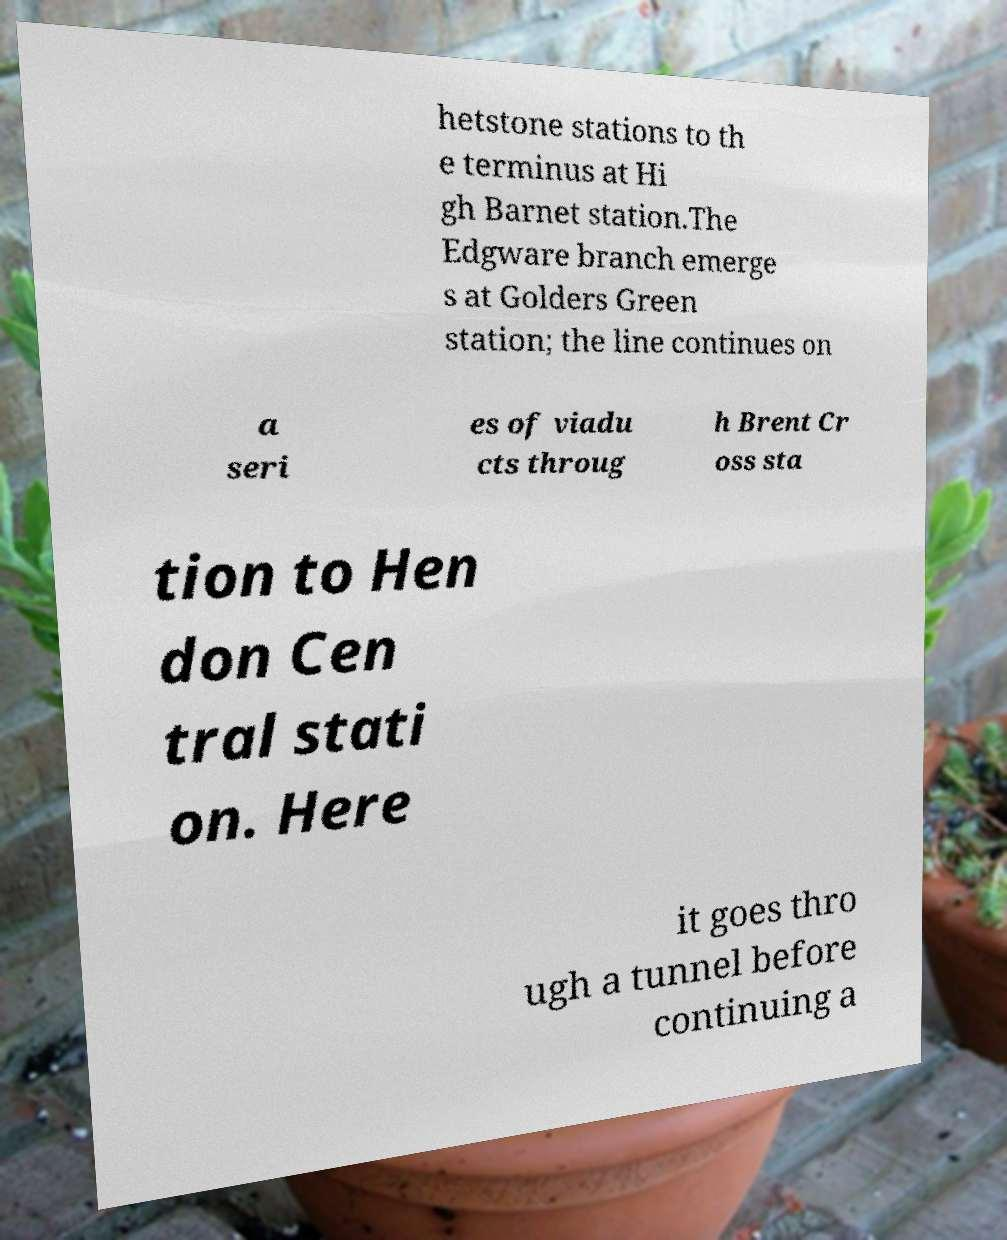Could you extract and type out the text from this image? hetstone stations to th e terminus at Hi gh Barnet station.The Edgware branch emerge s at Golders Green station; the line continues on a seri es of viadu cts throug h Brent Cr oss sta tion to Hen don Cen tral stati on. Here it goes thro ugh a tunnel before continuing a 